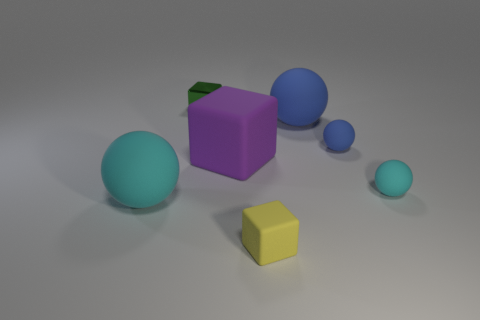What number of other yellow cubes are the same material as the yellow cube?
Make the answer very short. 0. What color is the block that is the same material as the small yellow thing?
Provide a succinct answer. Purple. What material is the yellow block in front of the big ball that is in front of the cyan thing to the right of the large matte block?
Your answer should be very brief. Rubber. There is a cyan matte object to the left of the yellow thing; is its size the same as the small yellow object?
Your response must be concise. No. How many tiny things are either blue spheres or cyan things?
Provide a succinct answer. 2. Is there a small metal cube of the same color as the small rubber block?
Offer a very short reply. No. What shape is the cyan thing that is the same size as the green shiny thing?
Offer a very short reply. Sphere. Is the color of the block that is behind the big purple matte cube the same as the small rubber block?
Provide a succinct answer. No. How many things are either tiny things behind the large cyan rubber ball or small brown matte things?
Your answer should be compact. 3. Is the number of small rubber spheres that are in front of the tiny yellow block greater than the number of small cyan rubber objects that are in front of the big cyan object?
Ensure brevity in your answer.  No. 